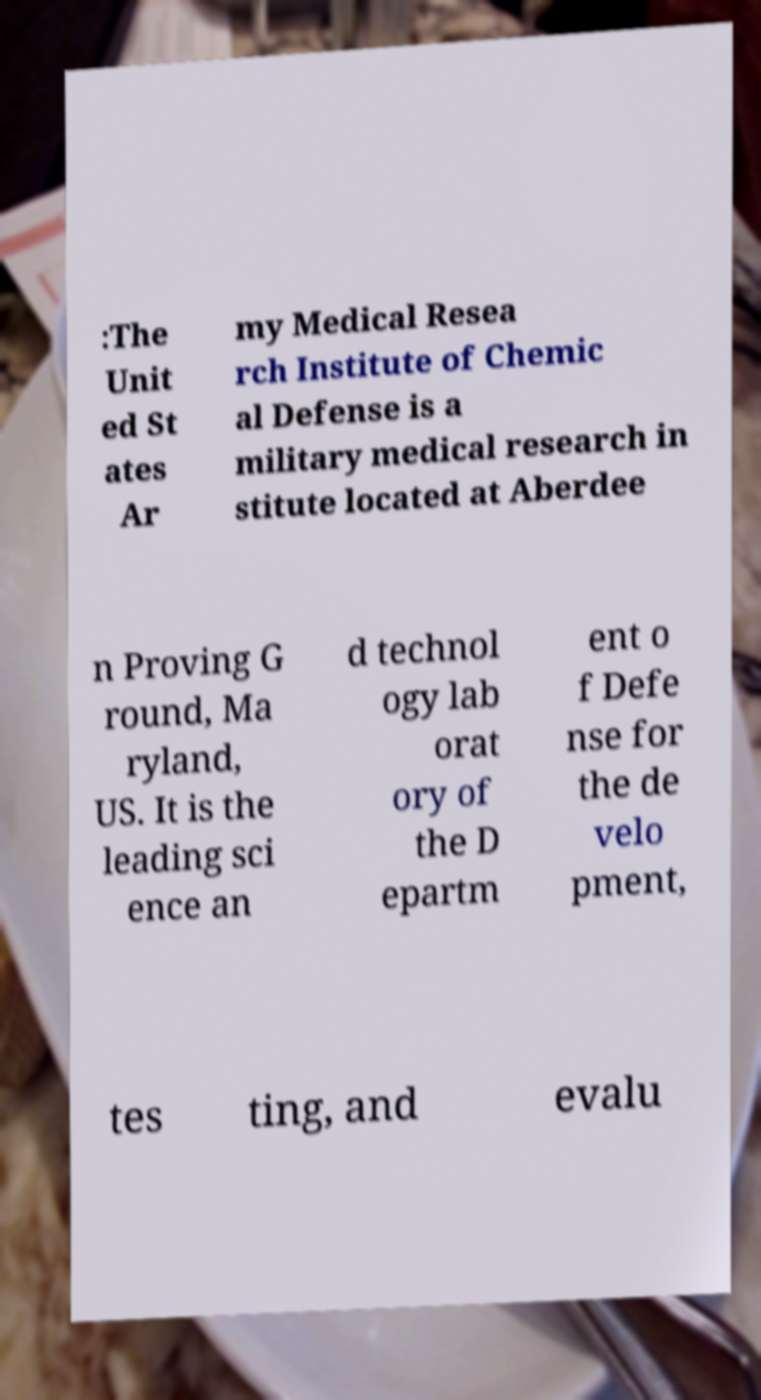What messages or text are displayed in this image? I need them in a readable, typed format. :The Unit ed St ates Ar my Medical Resea rch Institute of Chemic al Defense is a military medical research in stitute located at Aberdee n Proving G round, Ma ryland, US. It is the leading sci ence an d technol ogy lab orat ory of the D epartm ent o f Defe nse for the de velo pment, tes ting, and evalu 